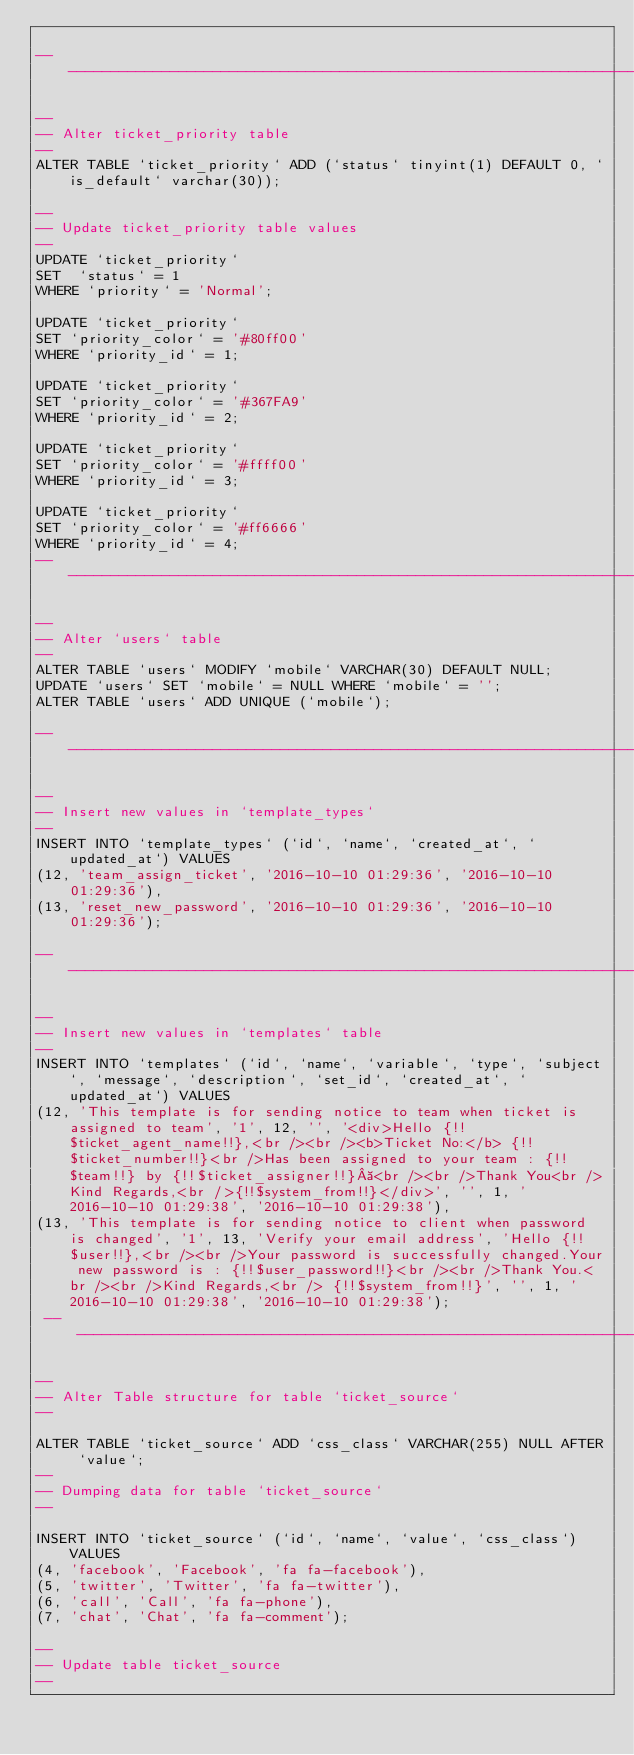<code> <loc_0><loc_0><loc_500><loc_500><_SQL_>
-- --------------------------------------------------------------------

-- 
-- Alter ticket_priority table
-- 
ALTER TABLE `ticket_priority` ADD (`status` tinyint(1) DEFAULT 0, `is_default` varchar(30));

-- 
-- Update ticket_priority table values
-- 
UPDATE `ticket_priority`
SET  `status` = 1
WHERE `priority` = 'Normal';

UPDATE `ticket_priority`
SET `priority_color` = '#80ff00'
WHERE `priority_id` = 1;

UPDATE `ticket_priority`
SET `priority_color` = '#367FA9'
WHERE `priority_id` = 2;

UPDATE `ticket_priority`
SET `priority_color` = '#ffff00'
WHERE `priority_id` = 3;

UPDATE `ticket_priority`
SET `priority_color` = '#ff6666'
WHERE `priority_id` = 4;
-- --------------------------------------------------------------------

-- 
-- Alter `users` table 
-- 
ALTER TABLE `users` MODIFY `mobile` VARCHAR(30) DEFAULT NULL;
UPDATE `users` SET `mobile` = NULL WHERE `mobile` = '';
ALTER TABLE `users` ADD UNIQUE (`mobile`);

-- ----------------------------------------------------------------------

-- 
-- Insert new values in `template_types` 
-- 
INSERT INTO `template_types` (`id`, `name`, `created_at`, `updated_at`) VALUES
(12, 'team_assign_ticket', '2016-10-10 01:29:36', '2016-10-10 01:29:36'),
(13, 'reset_new_password', '2016-10-10 01:29:36', '2016-10-10 01:29:36');

-- --------------------------------------------------------------------------

-- 
-- Insert new values in `templates` table
-- 
INSERT INTO `templates` (`id`, `name`, `variable`, `type`, `subject`, `message`, `description`, `set_id`, `created_at`, `updated_at`) VALUES
(12, 'This template is for sending notice to team when ticket is assigned to team', '1', 12, '', '<div>Hello {!!$ticket_agent_name!!},<br /><br /><b>Ticket No:</b> {!!$ticket_number!!}<br />Has been assigned to your team : {!!$team!!} by {!!$ticket_assigner!!} <br /><br />Thank You<br />Kind Regards,<br />{!!$system_from!!}</div>', '', 1, '2016-10-10 01:29:38', '2016-10-10 01:29:38'),
(13, 'This template is for sending notice to client when password is changed', '1', 13, 'Verify your email address', 'Hello {!!$user!!},<br /><br />Your password is successfully changed.Your new password is : {!!$user_password!!}<br /><br />Thank You.<br /><br />Kind Regards,<br /> {!!$system_from!!}', '', 1, '2016-10-10 01:29:38', '2016-10-10 01:29:38');
 -- --------------------------------------------------------------------------

-- 
-- Alter Table structure for table `ticket_source`
-- 

ALTER TABLE `ticket_source` ADD `css_class` VARCHAR(255) NULL AFTER `value`;
-- 
-- Dumping data for table `ticket_source`
-- 

INSERT INTO `ticket_source` (`id`, `name`, `value`, `css_class`) VALUES
(4, 'facebook', 'Facebook', 'fa fa-facebook'),
(5, 'twitter', 'Twitter', 'fa fa-twitter'),
(6, 'call', 'Call', 'fa fa-phone'),
(7, 'chat', 'Chat', 'fa fa-comment');

--  
-- Update table ticket_source
-- </code> 